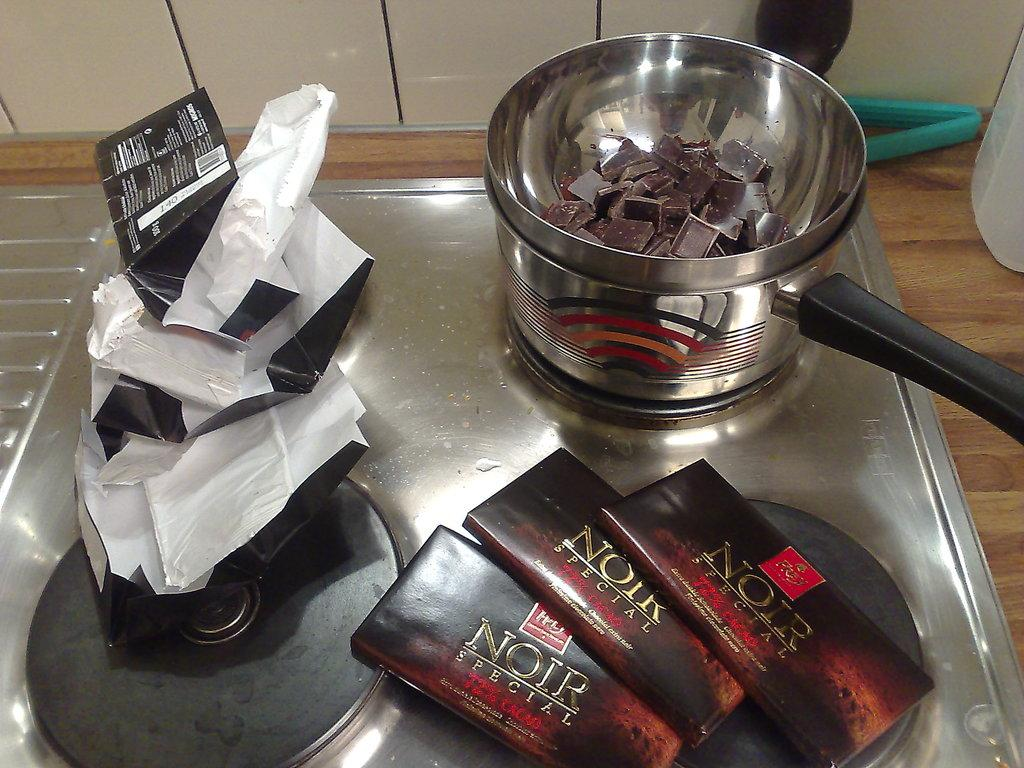<image>
Render a clear and concise summary of the photo. Noir chocolate bars are being melted next to rappers they were once in. 